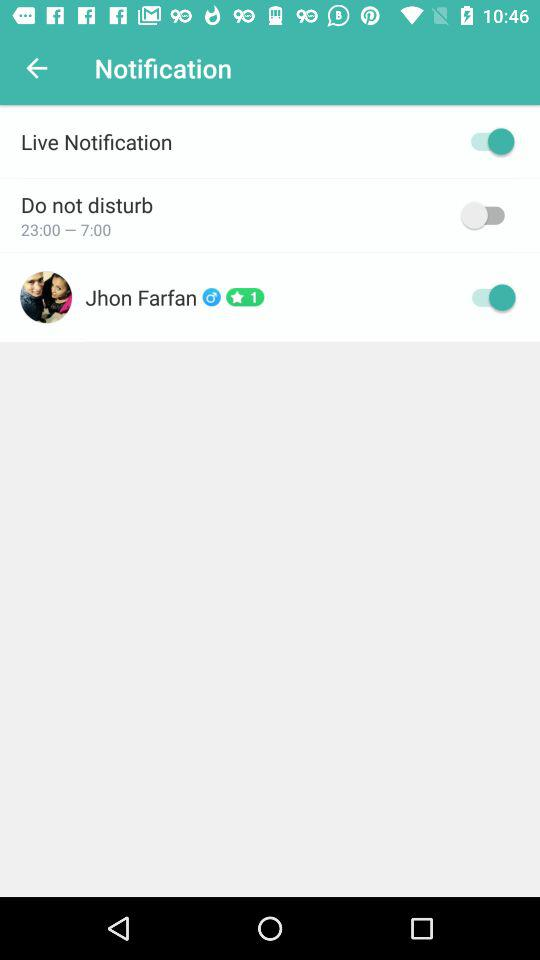What's the name of the user? The name of the user is "Jhon Farfan". 